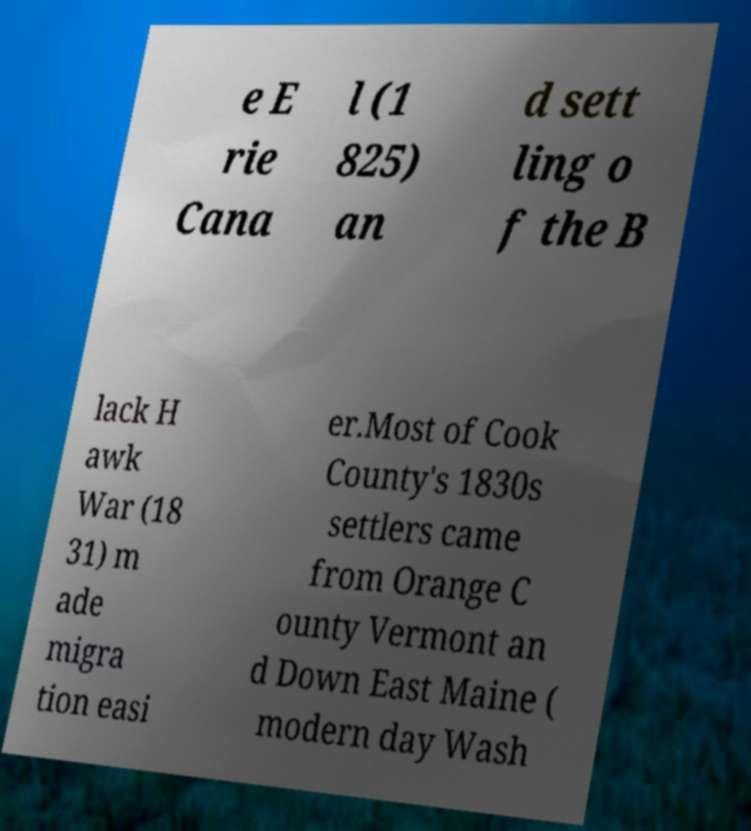I need the written content from this picture converted into text. Can you do that? e E rie Cana l (1 825) an d sett ling o f the B lack H awk War (18 31) m ade migra tion easi er.Most of Cook County's 1830s settlers came from Orange C ounty Vermont an d Down East Maine ( modern day Wash 